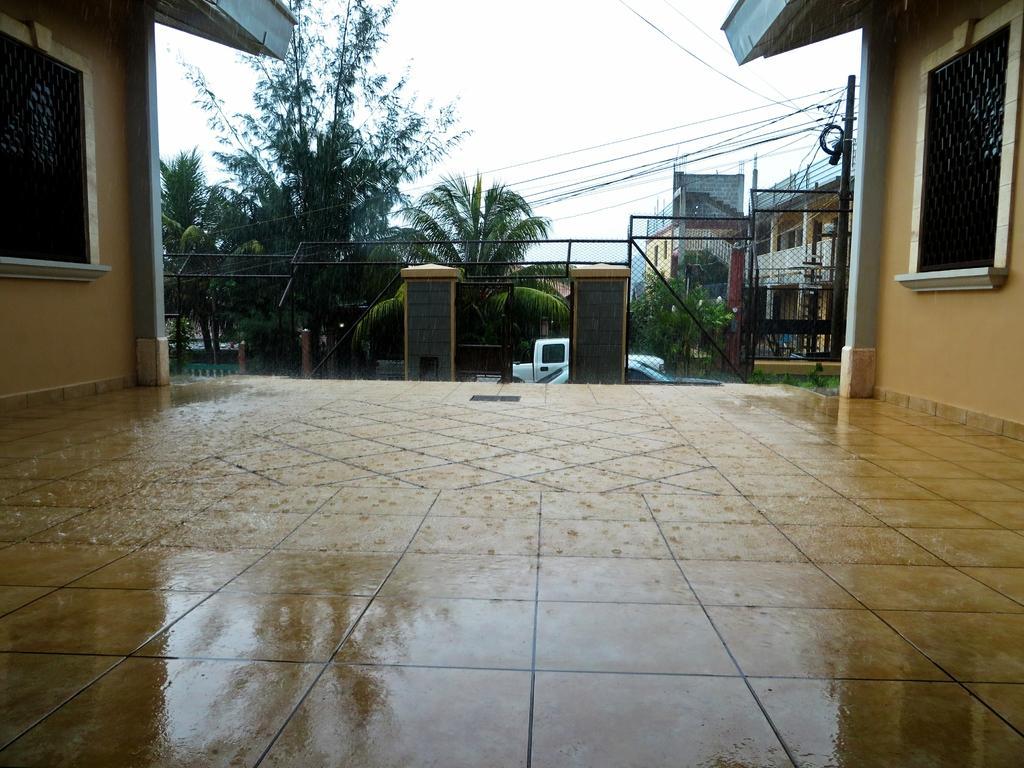How would you summarize this image in a sentence or two? In this image I can see floor with marbles. There is fencing, there are iron grilles and there are trees. There are buildings, there is a vehicle and there is an electric pole with cables. In the background there is sky. 